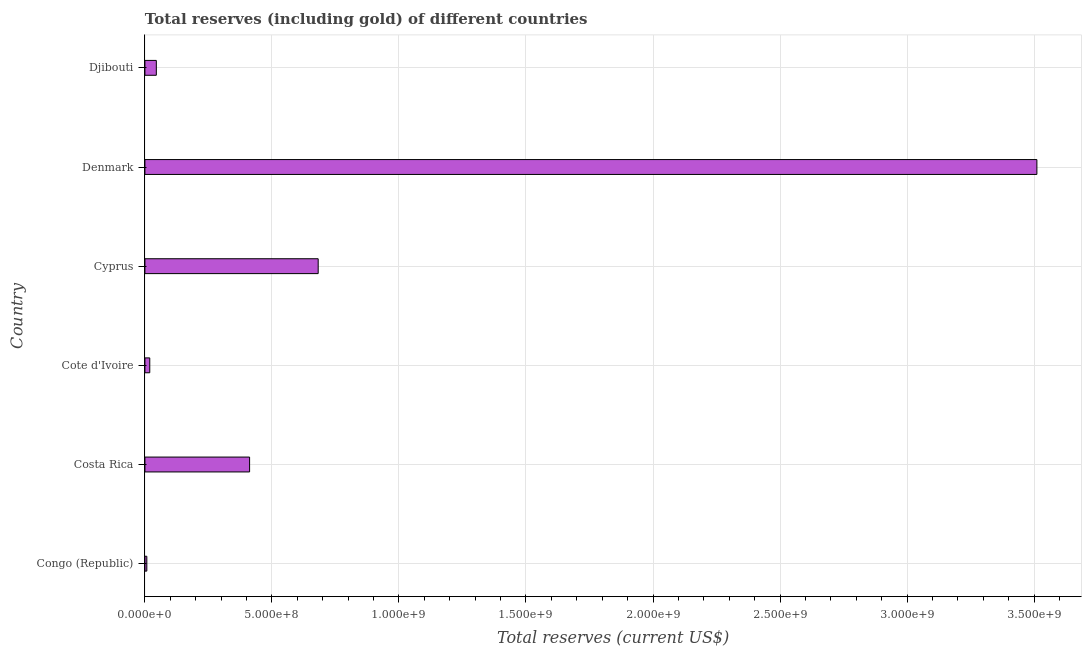Does the graph contain grids?
Offer a terse response. Yes. What is the title of the graph?
Keep it short and to the point. Total reserves (including gold) of different countries. What is the label or title of the X-axis?
Your answer should be compact. Total reserves (current US$). What is the label or title of the Y-axis?
Offer a terse response. Country. What is the total reserves (including gold) in Djibouti?
Ensure brevity in your answer.  4.49e+07. Across all countries, what is the maximum total reserves (including gold)?
Make the answer very short. 3.51e+09. Across all countries, what is the minimum total reserves (including gold)?
Ensure brevity in your answer.  7.54e+06. In which country was the total reserves (including gold) maximum?
Keep it short and to the point. Denmark. In which country was the total reserves (including gold) minimum?
Offer a terse response. Congo (Republic). What is the sum of the total reserves (including gold)?
Give a very brief answer. 4.68e+09. What is the difference between the total reserves (including gold) in Cote d'Ivoire and Denmark?
Provide a short and direct response. -3.49e+09. What is the average total reserves (including gold) per country?
Keep it short and to the point. 7.79e+08. What is the median total reserves (including gold)?
Offer a terse response. 2.29e+08. In how many countries, is the total reserves (including gold) greater than 1500000000 US$?
Give a very brief answer. 1. What is the ratio of the total reserves (including gold) in Congo (Republic) to that in Costa Rica?
Offer a terse response. 0.02. Is the difference between the total reserves (including gold) in Cyprus and Djibouti greater than the difference between any two countries?
Keep it short and to the point. No. What is the difference between the highest and the second highest total reserves (including gold)?
Make the answer very short. 2.83e+09. Is the sum of the total reserves (including gold) in Congo (Republic) and Denmark greater than the maximum total reserves (including gold) across all countries?
Your response must be concise. Yes. What is the difference between the highest and the lowest total reserves (including gold)?
Your answer should be compact. 3.50e+09. Are all the bars in the graph horizontal?
Your answer should be compact. Yes. Are the values on the major ticks of X-axis written in scientific E-notation?
Your answer should be compact. Yes. What is the Total reserves (current US$) in Congo (Republic)?
Provide a short and direct response. 7.54e+06. What is the Total reserves (current US$) in Costa Rica?
Ensure brevity in your answer.  4.12e+08. What is the Total reserves (current US$) of Cote d'Ivoire?
Provide a short and direct response. 1.91e+07. What is the Total reserves (current US$) of Cyprus?
Your answer should be very brief. 6.82e+08. What is the Total reserves (current US$) in Denmark?
Ensure brevity in your answer.  3.51e+09. What is the Total reserves (current US$) of Djibouti?
Provide a succinct answer. 4.49e+07. What is the difference between the Total reserves (current US$) in Congo (Republic) and Costa Rica?
Provide a short and direct response. -4.05e+08. What is the difference between the Total reserves (current US$) in Congo (Republic) and Cote d'Ivoire?
Your response must be concise. -1.16e+07. What is the difference between the Total reserves (current US$) in Congo (Republic) and Cyprus?
Keep it short and to the point. -6.75e+08. What is the difference between the Total reserves (current US$) in Congo (Republic) and Denmark?
Make the answer very short. -3.50e+09. What is the difference between the Total reserves (current US$) in Congo (Republic) and Djibouti?
Provide a short and direct response. -3.74e+07. What is the difference between the Total reserves (current US$) in Costa Rica and Cote d'Ivoire?
Your response must be concise. 3.93e+08. What is the difference between the Total reserves (current US$) in Costa Rica and Cyprus?
Your response must be concise. -2.70e+08. What is the difference between the Total reserves (current US$) in Costa Rica and Denmark?
Ensure brevity in your answer.  -3.10e+09. What is the difference between the Total reserves (current US$) in Costa Rica and Djibouti?
Provide a succinct answer. 3.67e+08. What is the difference between the Total reserves (current US$) in Cote d'Ivoire and Cyprus?
Your response must be concise. -6.63e+08. What is the difference between the Total reserves (current US$) in Cote d'Ivoire and Denmark?
Offer a very short reply. -3.49e+09. What is the difference between the Total reserves (current US$) in Cote d'Ivoire and Djibouti?
Ensure brevity in your answer.  -2.58e+07. What is the difference between the Total reserves (current US$) in Cyprus and Denmark?
Offer a very short reply. -2.83e+09. What is the difference between the Total reserves (current US$) in Cyprus and Djibouti?
Your response must be concise. 6.37e+08. What is the difference between the Total reserves (current US$) in Denmark and Djibouti?
Give a very brief answer. 3.47e+09. What is the ratio of the Total reserves (current US$) in Congo (Republic) to that in Costa Rica?
Provide a succinct answer. 0.02. What is the ratio of the Total reserves (current US$) in Congo (Republic) to that in Cote d'Ivoire?
Offer a very short reply. 0.4. What is the ratio of the Total reserves (current US$) in Congo (Republic) to that in Cyprus?
Your response must be concise. 0.01. What is the ratio of the Total reserves (current US$) in Congo (Republic) to that in Denmark?
Your answer should be very brief. 0. What is the ratio of the Total reserves (current US$) in Congo (Republic) to that in Djibouti?
Ensure brevity in your answer.  0.17. What is the ratio of the Total reserves (current US$) in Costa Rica to that in Cote d'Ivoire?
Ensure brevity in your answer.  21.59. What is the ratio of the Total reserves (current US$) in Costa Rica to that in Cyprus?
Offer a terse response. 0.6. What is the ratio of the Total reserves (current US$) in Costa Rica to that in Denmark?
Provide a short and direct response. 0.12. What is the ratio of the Total reserves (current US$) in Costa Rica to that in Djibouti?
Your answer should be very brief. 9.17. What is the ratio of the Total reserves (current US$) in Cote d'Ivoire to that in Cyprus?
Give a very brief answer. 0.03. What is the ratio of the Total reserves (current US$) in Cote d'Ivoire to that in Denmark?
Provide a short and direct response. 0.01. What is the ratio of the Total reserves (current US$) in Cote d'Ivoire to that in Djibouti?
Offer a very short reply. 0.42. What is the ratio of the Total reserves (current US$) in Cyprus to that in Denmark?
Provide a short and direct response. 0.19. What is the ratio of the Total reserves (current US$) in Cyprus to that in Djibouti?
Make the answer very short. 15.18. What is the ratio of the Total reserves (current US$) in Denmark to that in Djibouti?
Give a very brief answer. 78.14. 